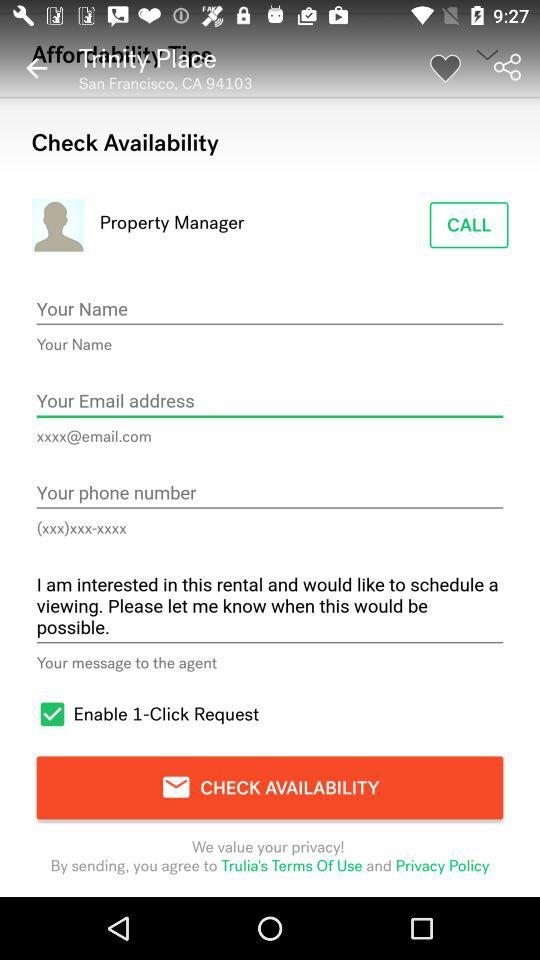How many inputs are there for contact information?
Answer the question using a single word or phrase. 3 